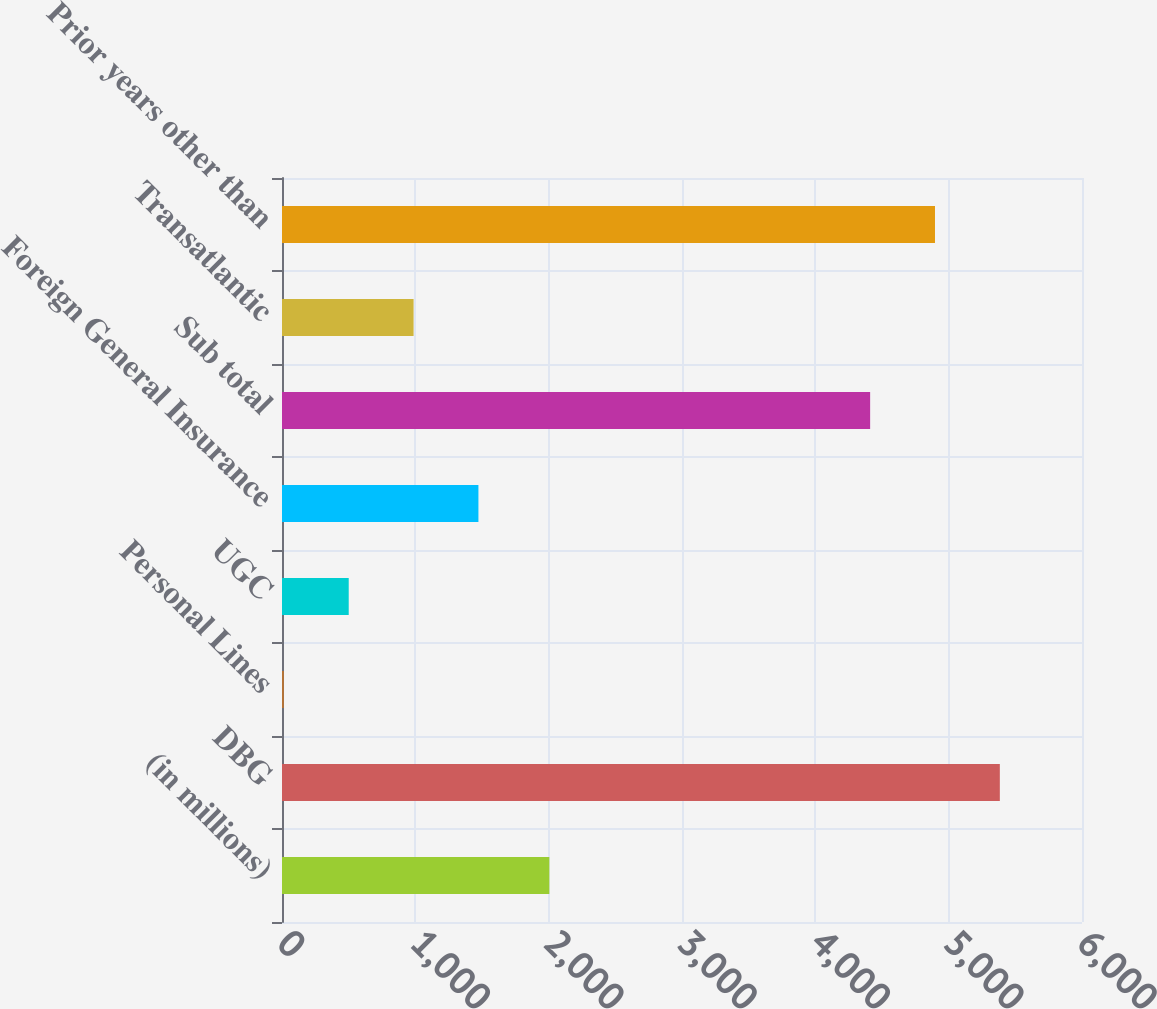Convert chart. <chart><loc_0><loc_0><loc_500><loc_500><bar_chart><fcel>(in millions)<fcel>DBG<fcel>Personal Lines<fcel>UGC<fcel>Foreign General Insurance<fcel>Sub total<fcel>Transatlantic<fcel>Prior years other than<nl><fcel>2005<fcel>5383.8<fcel>14<fcel>500.4<fcel>1473.2<fcel>4411<fcel>986.8<fcel>4897.4<nl></chart> 